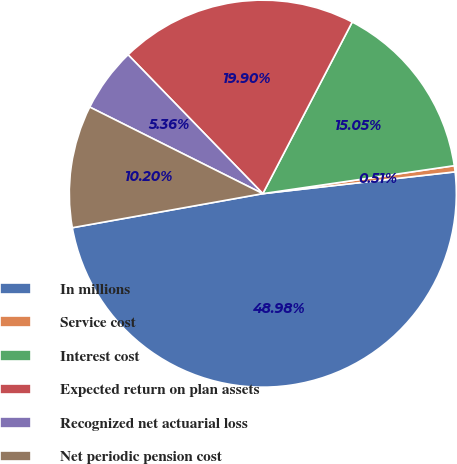Convert chart. <chart><loc_0><loc_0><loc_500><loc_500><pie_chart><fcel>In millions<fcel>Service cost<fcel>Interest cost<fcel>Expected return on plan assets<fcel>Recognized net actuarial loss<fcel>Net periodic pension cost<nl><fcel>48.98%<fcel>0.51%<fcel>15.05%<fcel>19.9%<fcel>5.36%<fcel>10.2%<nl></chart> 